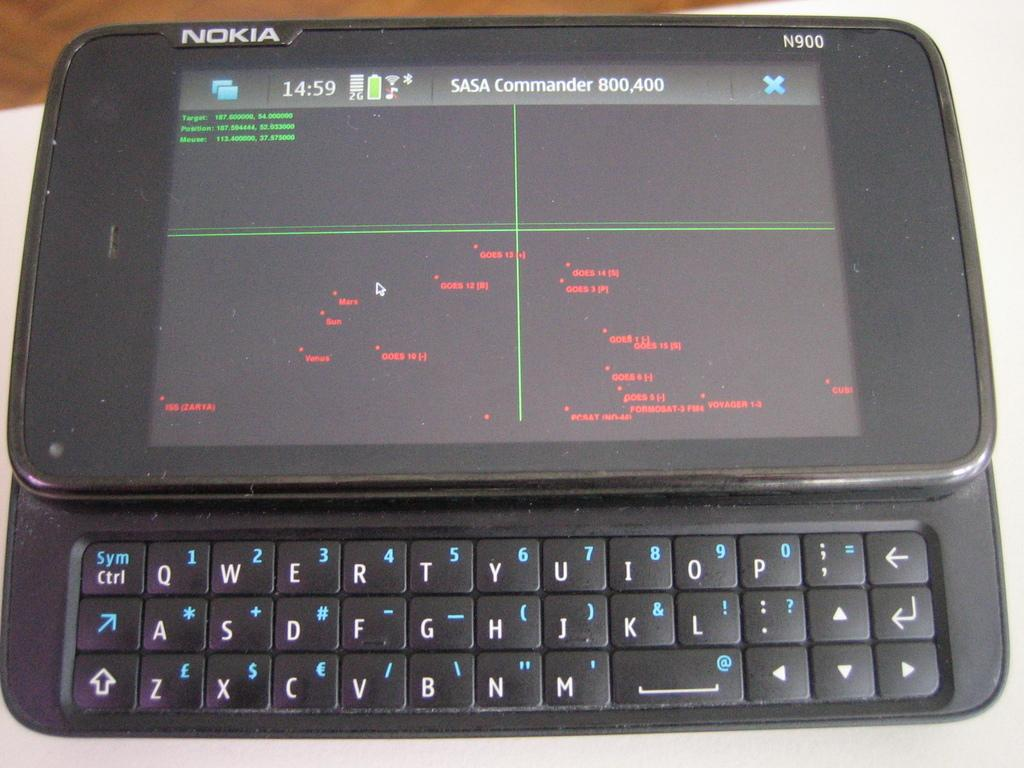Provide a one-sentence caption for the provided image. An old Nokia phone with SASA Commander on the screen. 